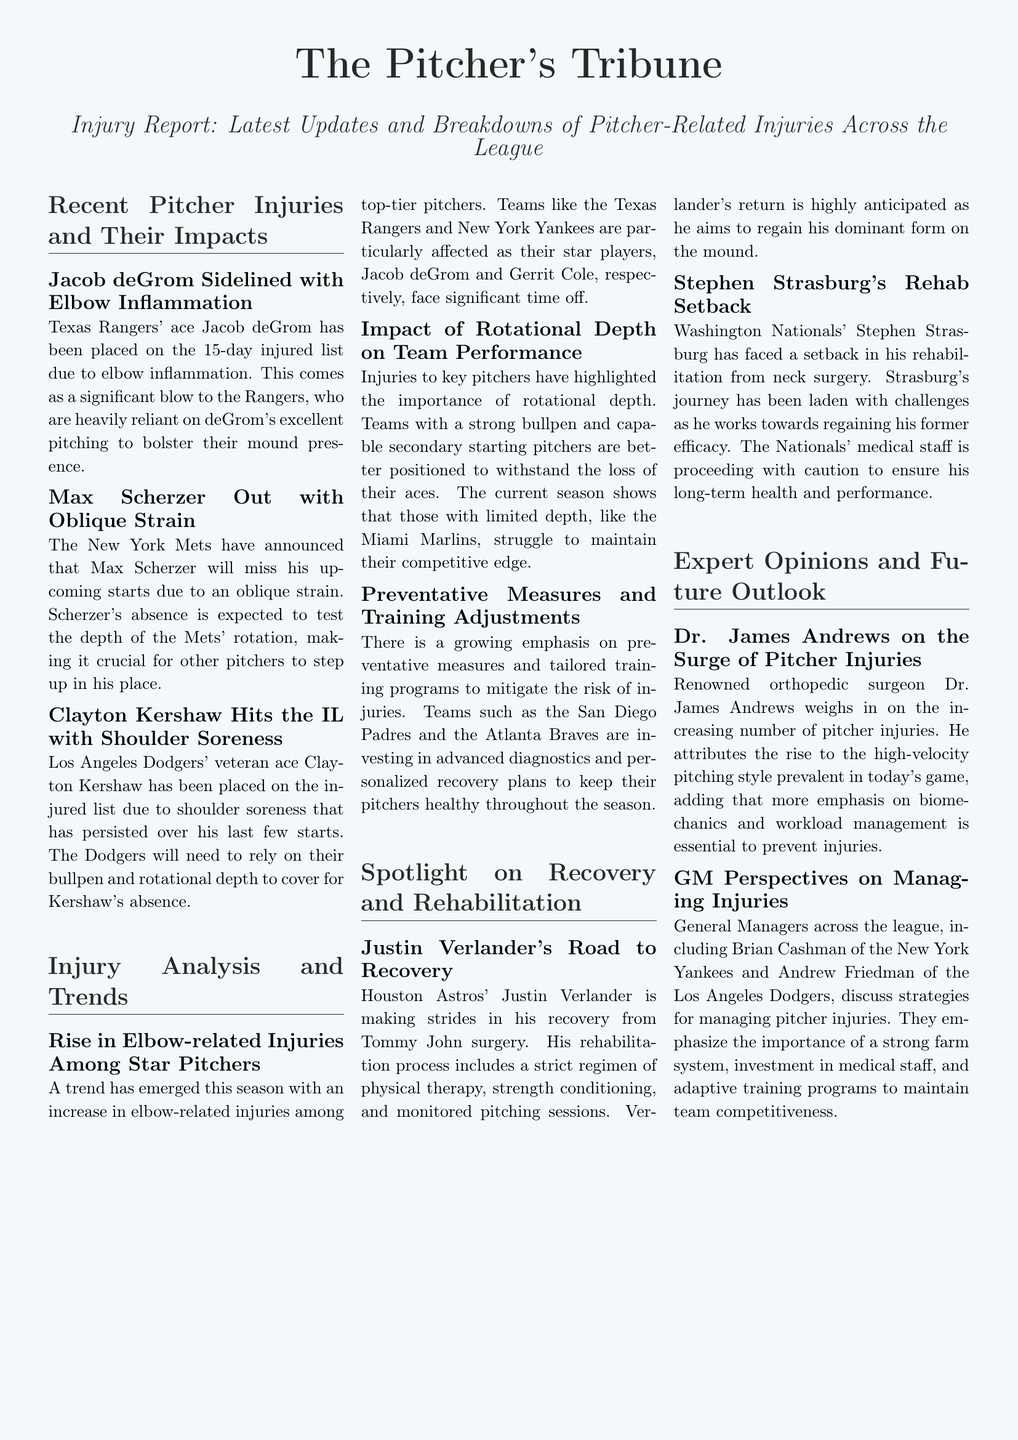What is the title of the article? The title of the article is found at the top of the document, stating what the content is about.
Answer: Injury Report: Latest Updates and Breakdowns of Pitcher-Related Injuries Across the League Who is sidelined with elbow inflammation? The document mentions specific players and their injuries, with one identified with elbow inflammation.
Answer: Jacob deGrom Which team's pitcher is Max Scherzer? The document lists the players and their respective teams, with Max Scherzer associated with one.
Answer: New York Mets What injury has Clayton Kershaw sustained? The document specifies the nature of Kershaw's injury within the context of the report.
Answer: Shoulder soreness How many days is deGrom on the injured list? The article states the duration for which deGrom is on the injured list.
Answer: 15 days What has increased among star pitchers this season? The document notes a trend observed this season regarding certain injuries.
Answer: Elbow-related injuries Which teams are investing in advanced diagnostics? The article highlights teams focusing on specific measures to avoid injuries, mentioning them expressly.
Answer: San Diego Padres and Atlanta Braves Who discussed strategies for managing pitcher injuries? The report includes perspectives from a specific group of individuals addressing injury management.
Answer: General Managers What is the role of Dr. James Andrews in the report? The document details the contributions of a specific expert related to the injuries discussed.
Answer: Orthopedic surgeon 